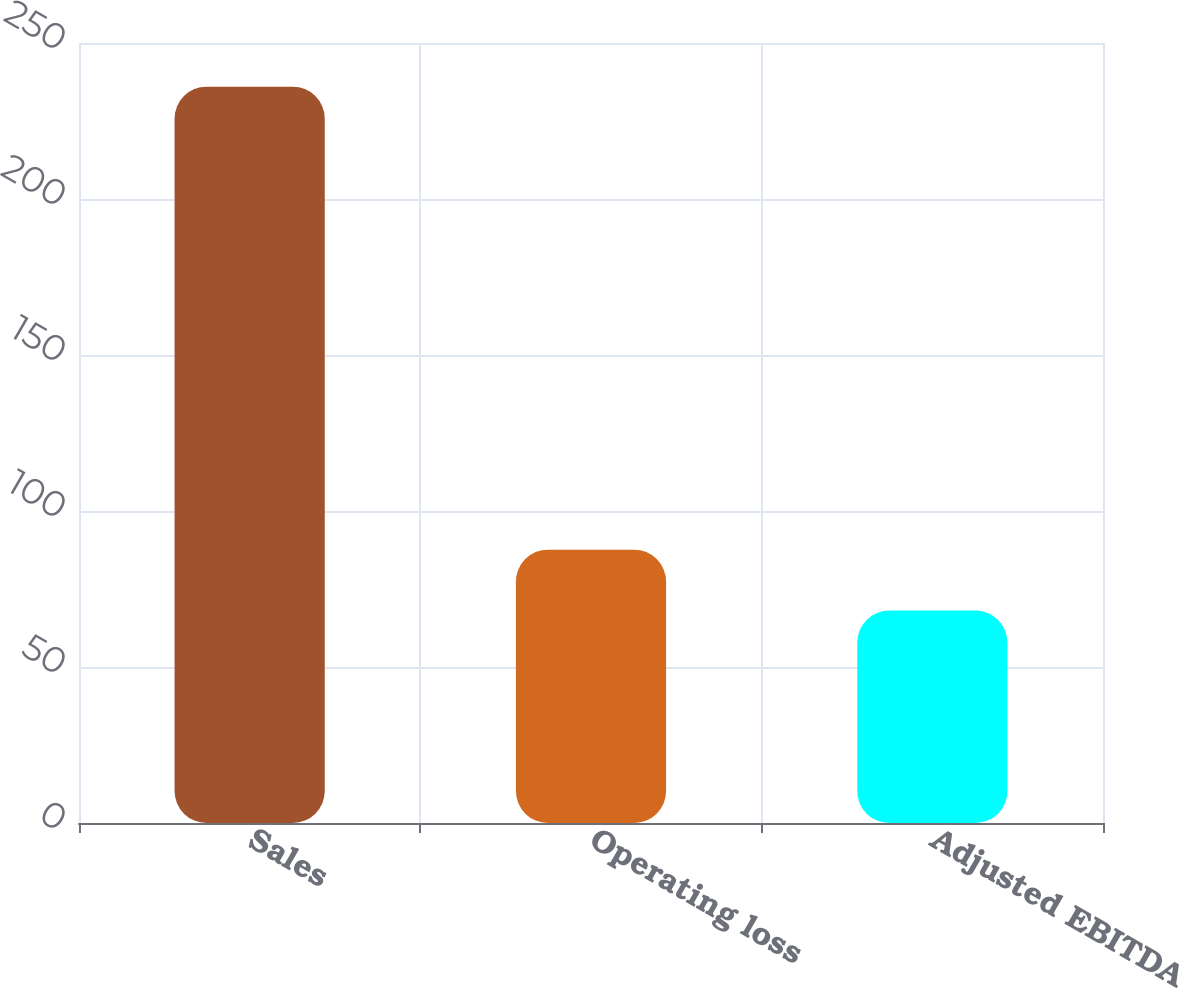Convert chart to OTSL. <chart><loc_0><loc_0><loc_500><loc_500><bar_chart><fcel>Sales<fcel>Operating loss<fcel>Adjusted EBITDA<nl><fcel>236<fcel>87.6<fcel>68.1<nl></chart> 